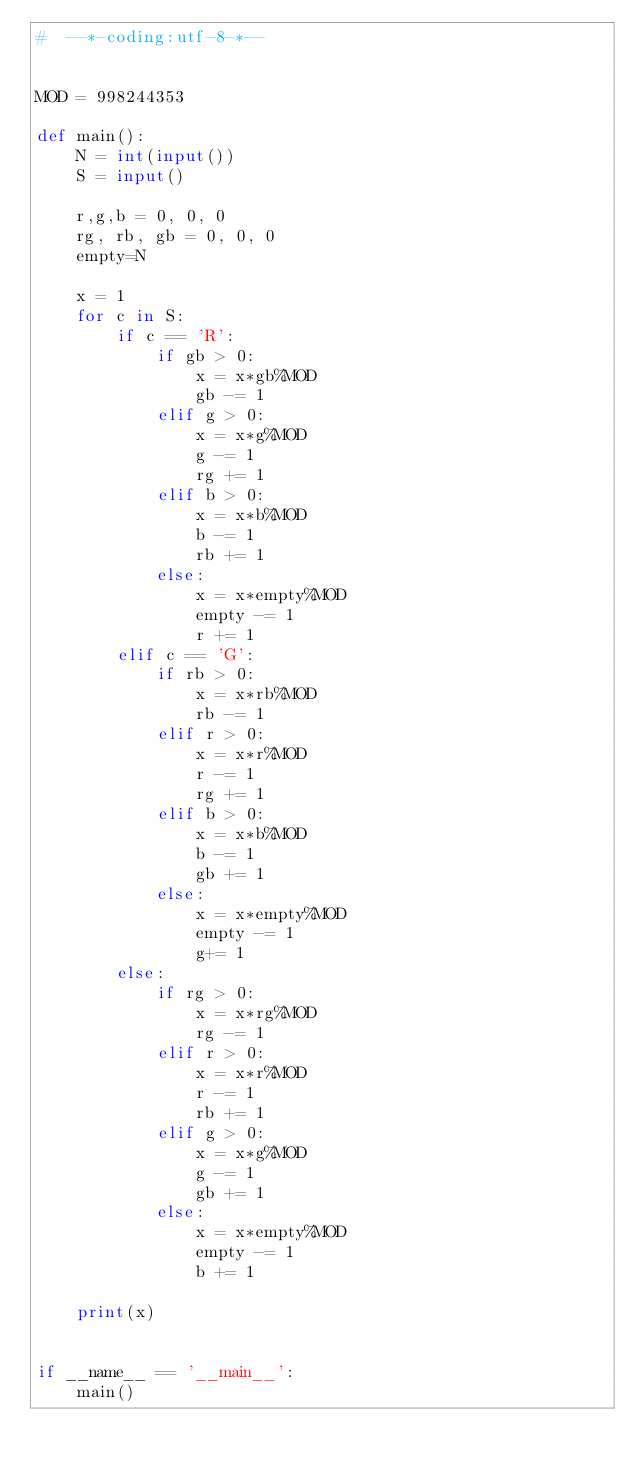Convert code to text. <code><loc_0><loc_0><loc_500><loc_500><_Python_>#  --*-coding:utf-8-*--


MOD = 998244353

def main():
    N = int(input())
    S = input()

    r,g,b = 0, 0, 0
    rg, rb, gb = 0, 0, 0
    empty=N

    x = 1
    for c in S:
        if c == 'R':
            if gb > 0:
                x = x*gb%MOD
                gb -= 1
            elif g > 0:
                x = x*g%MOD
                g -= 1
                rg += 1
            elif b > 0:
                x = x*b%MOD
                b -= 1
                rb += 1
            else:
                x = x*empty%MOD
                empty -= 1
                r += 1
        elif c == 'G':
            if rb > 0:
                x = x*rb%MOD
                rb -= 1
            elif r > 0:
                x = x*r%MOD
                r -= 1
                rg += 1
            elif b > 0:
                x = x*b%MOD
                b -= 1
                gb += 1
            else:
                x = x*empty%MOD
                empty -= 1
                g+= 1
        else:
            if rg > 0:
                x = x*rg%MOD
                rg -= 1
            elif r > 0:
                x = x*r%MOD
                r -= 1
                rb += 1
            elif g > 0:
                x = x*g%MOD
                g -= 1
                gb += 1
            else:
                x = x*empty%MOD
                empty -= 1
                b += 1

    print(x)
                

if __name__ == '__main__':
    main()
</code> 